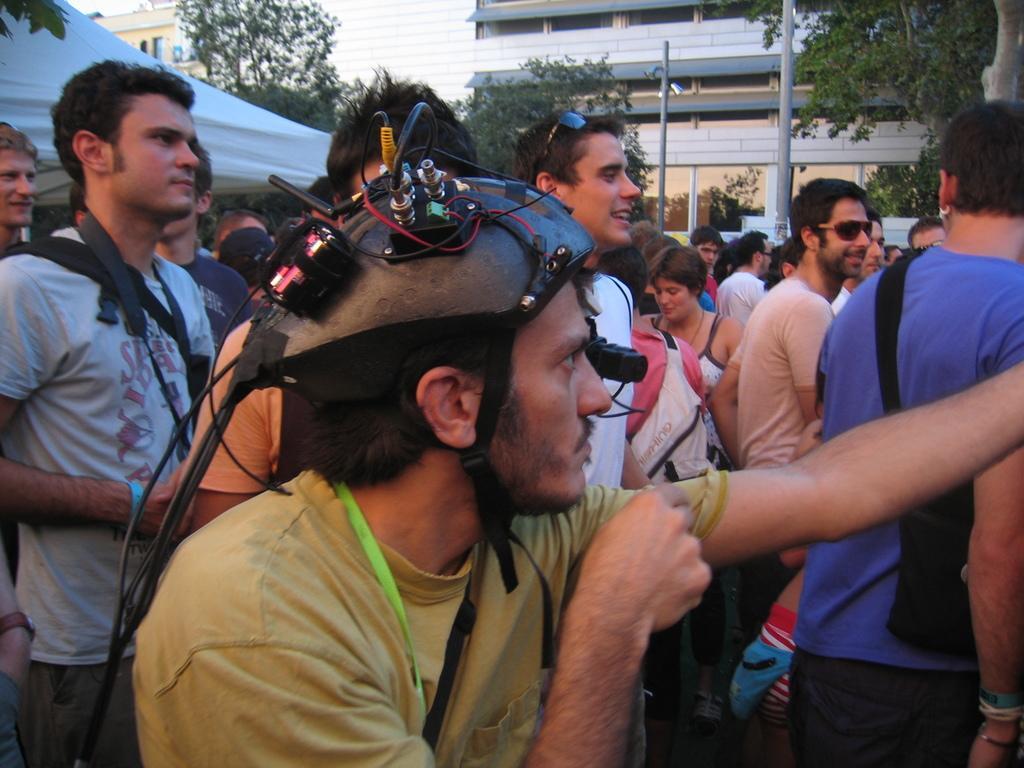Please provide a concise description of this image. In this picture there is a person wearing yellow color T shirt and a device on his head. There are some people standing. We can observe men and women in this picture. On the left side there is a white color tint. In the background there are trees, poles and a building. We can observe a sky. 